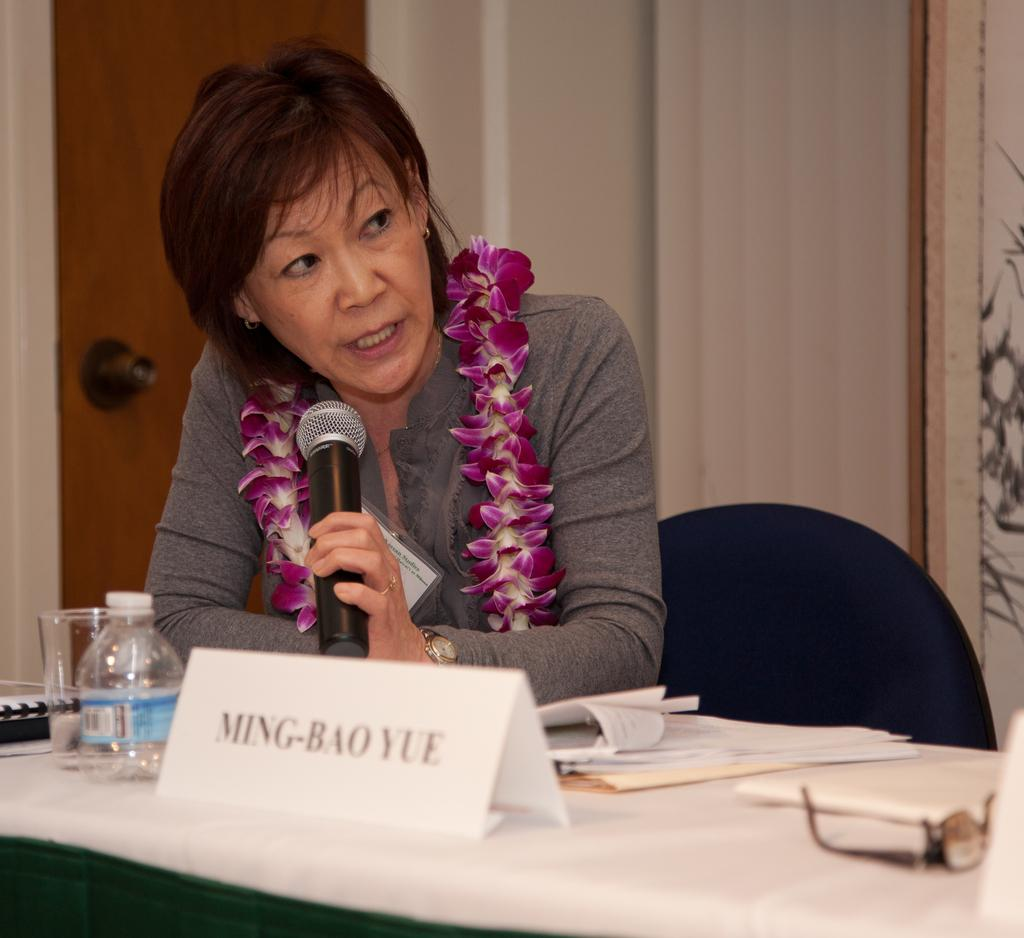What is the woman doing in the image? She is sitting on a chair and holding a mic. What objects are present on the table in the image? There is a table in the image with a name board, a bottle, a glass, and a keyboard on it. What is the purpose of the name board? The name board is likely used to display her name or the event she is participating in. What type of stone is being used to support the coil in the image? There is no stone or coil present in the image. 